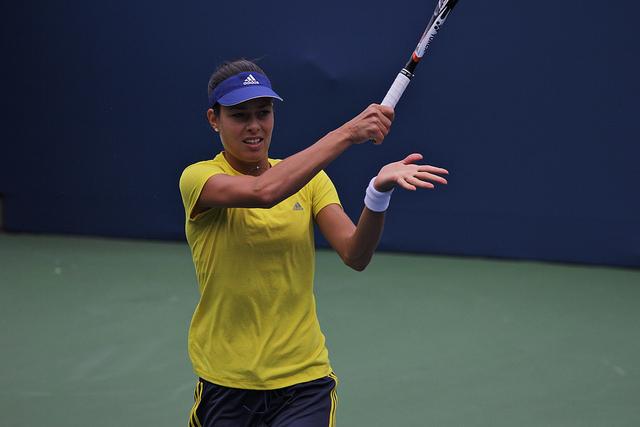Is she happy with her performance at this moment?
Keep it brief. Yes. What color is her bracelet?
Answer briefly. White. What color is his hat?
Concise answer only. Blue. Is this a professional game?
Answer briefly. Yes. Which arm has the sweat band?
Give a very brief answer. Left. Did the girl just swing the racket?
Keep it brief. Yes. What color is the background?
Answer briefly. Blue. 